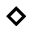Convert formula to latex. <formula><loc_0><loc_0><loc_500><loc_500>\diamond</formula> 